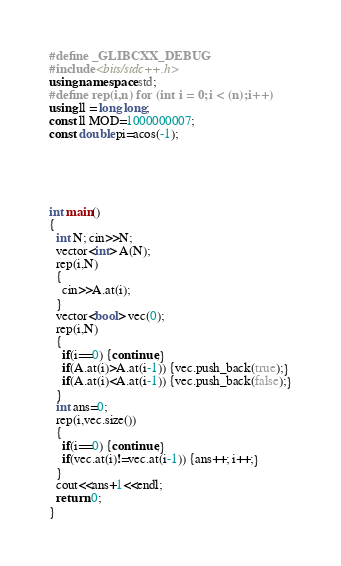Convert code to text. <code><loc_0><loc_0><loc_500><loc_500><_C++_>#define _GLIBCXX_DEBUG
#include <bits/stdc++.h>
using namespace std;
#define rep(i,n) for (int i = 0;i < (n);i++)
using ll = long long;
const ll MOD=1000000007;
const double pi=acos(-1);





int main() 
{
  int N; cin>>N;
  vector<int> A(N);
  rep(i,N)
  {
    cin>>A.at(i);
  }
  vector<bool> vec(0);
  rep(i,N)
  {
    if(i==0) {continue;}
    if(A.at(i)>A.at(i-1)) {vec.push_back(true);}
    if(A.at(i)<A.at(i-1)) {vec.push_back(false);}
  }
  int ans=0;
  rep(i,vec.size())
  {
    if(i==0) {continue;}
    if(vec.at(i)!=vec.at(i-1)) {ans++; i++;}
  }
  cout<<ans+1<<endl;
  return 0;
}
</code> 